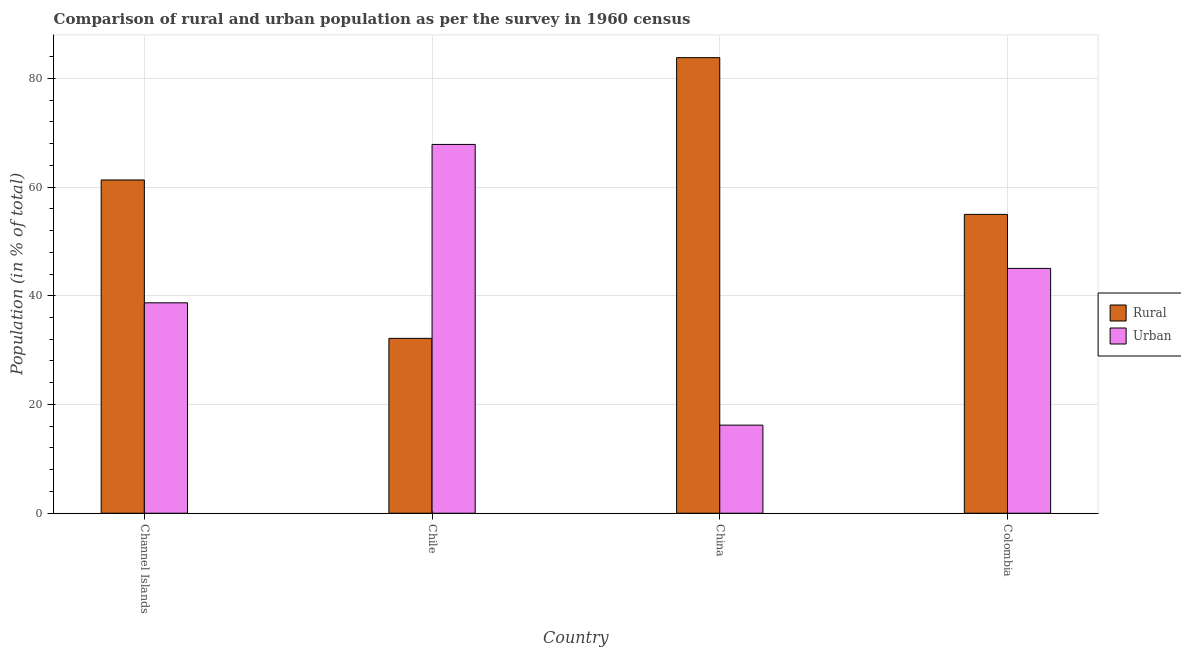How many groups of bars are there?
Make the answer very short. 4. Are the number of bars on each tick of the X-axis equal?
Offer a very short reply. Yes. In how many cases, is the number of bars for a given country not equal to the number of legend labels?
Offer a terse response. 0. What is the urban population in Colombia?
Provide a short and direct response. 45.03. Across all countries, what is the maximum rural population?
Keep it short and to the point. 83.8. Across all countries, what is the minimum urban population?
Give a very brief answer. 16.2. In which country was the urban population minimum?
Your response must be concise. China. What is the total urban population in the graph?
Make the answer very short. 167.77. What is the difference between the urban population in Channel Islands and that in Colombia?
Provide a succinct answer. -6.33. What is the difference between the urban population in China and the rural population in Chile?
Provide a succinct answer. -15.96. What is the average urban population per country?
Keep it short and to the point. 41.94. What is the difference between the rural population and urban population in Colombia?
Give a very brief answer. 9.93. In how many countries, is the urban population greater than 68 %?
Keep it short and to the point. 0. What is the ratio of the urban population in Channel Islands to that in Colombia?
Your answer should be very brief. 0.86. Is the difference between the urban population in Channel Islands and Chile greater than the difference between the rural population in Channel Islands and Chile?
Give a very brief answer. No. What is the difference between the highest and the second highest rural population?
Offer a very short reply. 22.5. What is the difference between the highest and the lowest urban population?
Offer a terse response. 51.63. What does the 2nd bar from the left in China represents?
Your answer should be very brief. Urban. What does the 1st bar from the right in Chile represents?
Your answer should be compact. Urban. How many bars are there?
Ensure brevity in your answer.  8. Are all the bars in the graph horizontal?
Your answer should be compact. No. Are the values on the major ticks of Y-axis written in scientific E-notation?
Keep it short and to the point. No. Does the graph contain any zero values?
Offer a terse response. No. Does the graph contain grids?
Provide a succinct answer. Yes. Where does the legend appear in the graph?
Keep it short and to the point. Center right. How are the legend labels stacked?
Offer a terse response. Vertical. What is the title of the graph?
Give a very brief answer. Comparison of rural and urban population as per the survey in 1960 census. Does "Electricity" appear as one of the legend labels in the graph?
Your answer should be very brief. No. What is the label or title of the Y-axis?
Provide a short and direct response. Population (in % of total). What is the Population (in % of total) in Rural in Channel Islands?
Provide a short and direct response. 61.3. What is the Population (in % of total) in Urban in Channel Islands?
Ensure brevity in your answer.  38.7. What is the Population (in % of total) in Rural in Chile?
Provide a short and direct response. 32.16. What is the Population (in % of total) in Urban in Chile?
Your answer should be very brief. 67.84. What is the Population (in % of total) of Rural in China?
Offer a terse response. 83.8. What is the Population (in % of total) in Urban in China?
Offer a very short reply. 16.2. What is the Population (in % of total) of Rural in Colombia?
Provide a succinct answer. 54.97. What is the Population (in % of total) of Urban in Colombia?
Your answer should be compact. 45.03. Across all countries, what is the maximum Population (in % of total) in Rural?
Your answer should be very brief. 83.8. Across all countries, what is the maximum Population (in % of total) in Urban?
Offer a very short reply. 67.84. Across all countries, what is the minimum Population (in % of total) in Rural?
Your answer should be very brief. 32.16. Across all countries, what is the minimum Population (in % of total) in Urban?
Your answer should be compact. 16.2. What is the total Population (in % of total) in Rural in the graph?
Provide a short and direct response. 232.23. What is the total Population (in % of total) of Urban in the graph?
Keep it short and to the point. 167.77. What is the difference between the Population (in % of total) of Rural in Channel Islands and that in Chile?
Your answer should be very brief. 29.14. What is the difference between the Population (in % of total) in Urban in Channel Islands and that in Chile?
Keep it short and to the point. -29.14. What is the difference between the Population (in % of total) of Rural in Channel Islands and that in China?
Your answer should be compact. -22.5. What is the difference between the Population (in % of total) of Urban in Channel Islands and that in China?
Your response must be concise. 22.5. What is the difference between the Population (in % of total) of Rural in Channel Islands and that in Colombia?
Your answer should be compact. 6.33. What is the difference between the Population (in % of total) in Urban in Channel Islands and that in Colombia?
Make the answer very short. -6.33. What is the difference between the Population (in % of total) of Rural in Chile and that in China?
Ensure brevity in your answer.  -51.63. What is the difference between the Population (in % of total) in Urban in Chile and that in China?
Provide a short and direct response. 51.63. What is the difference between the Population (in % of total) of Rural in Chile and that in Colombia?
Your answer should be compact. -22.8. What is the difference between the Population (in % of total) in Urban in Chile and that in Colombia?
Ensure brevity in your answer.  22.8. What is the difference between the Population (in % of total) in Rural in China and that in Colombia?
Keep it short and to the point. 28.83. What is the difference between the Population (in % of total) of Urban in China and that in Colombia?
Provide a short and direct response. -28.83. What is the difference between the Population (in % of total) in Rural in Channel Islands and the Population (in % of total) in Urban in Chile?
Keep it short and to the point. -6.54. What is the difference between the Population (in % of total) in Rural in Channel Islands and the Population (in % of total) in Urban in China?
Your response must be concise. 45.1. What is the difference between the Population (in % of total) in Rural in Channel Islands and the Population (in % of total) in Urban in Colombia?
Keep it short and to the point. 16.27. What is the difference between the Population (in % of total) of Rural in Chile and the Population (in % of total) of Urban in China?
Keep it short and to the point. 15.96. What is the difference between the Population (in % of total) of Rural in Chile and the Population (in % of total) of Urban in Colombia?
Make the answer very short. -12.87. What is the difference between the Population (in % of total) in Rural in China and the Population (in % of total) in Urban in Colombia?
Ensure brevity in your answer.  38.76. What is the average Population (in % of total) in Rural per country?
Provide a succinct answer. 58.06. What is the average Population (in % of total) of Urban per country?
Your answer should be compact. 41.94. What is the difference between the Population (in % of total) in Rural and Population (in % of total) in Urban in Channel Islands?
Your response must be concise. 22.6. What is the difference between the Population (in % of total) in Rural and Population (in % of total) in Urban in Chile?
Keep it short and to the point. -35.67. What is the difference between the Population (in % of total) of Rural and Population (in % of total) of Urban in China?
Provide a short and direct response. 67.59. What is the difference between the Population (in % of total) of Rural and Population (in % of total) of Urban in Colombia?
Give a very brief answer. 9.93. What is the ratio of the Population (in % of total) in Rural in Channel Islands to that in Chile?
Your answer should be very brief. 1.91. What is the ratio of the Population (in % of total) of Urban in Channel Islands to that in Chile?
Ensure brevity in your answer.  0.57. What is the ratio of the Population (in % of total) of Rural in Channel Islands to that in China?
Provide a short and direct response. 0.73. What is the ratio of the Population (in % of total) in Urban in Channel Islands to that in China?
Make the answer very short. 2.39. What is the ratio of the Population (in % of total) of Rural in Channel Islands to that in Colombia?
Keep it short and to the point. 1.12. What is the ratio of the Population (in % of total) of Urban in Channel Islands to that in Colombia?
Provide a short and direct response. 0.86. What is the ratio of the Population (in % of total) of Rural in Chile to that in China?
Your response must be concise. 0.38. What is the ratio of the Population (in % of total) of Urban in Chile to that in China?
Provide a short and direct response. 4.19. What is the ratio of the Population (in % of total) in Rural in Chile to that in Colombia?
Give a very brief answer. 0.59. What is the ratio of the Population (in % of total) of Urban in Chile to that in Colombia?
Offer a very short reply. 1.51. What is the ratio of the Population (in % of total) in Rural in China to that in Colombia?
Your answer should be compact. 1.52. What is the ratio of the Population (in % of total) in Urban in China to that in Colombia?
Provide a succinct answer. 0.36. What is the difference between the highest and the second highest Population (in % of total) in Rural?
Your response must be concise. 22.5. What is the difference between the highest and the second highest Population (in % of total) in Urban?
Keep it short and to the point. 22.8. What is the difference between the highest and the lowest Population (in % of total) of Rural?
Keep it short and to the point. 51.63. What is the difference between the highest and the lowest Population (in % of total) in Urban?
Your response must be concise. 51.63. 